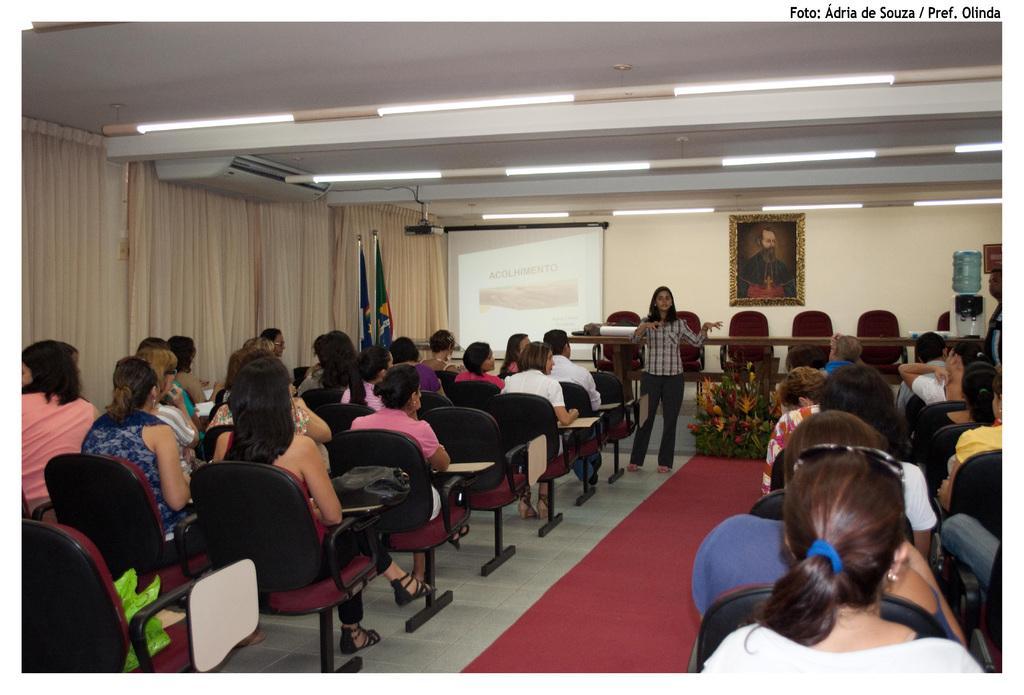Can you describe this image briefly? In this image there are group of people who are sitting on chairs on the right side and left side and on the top there is ceiling and some lights are there and on the left side there is curtains and some flags are there and in the center there is one screen beside that screen there is one photo frame. 